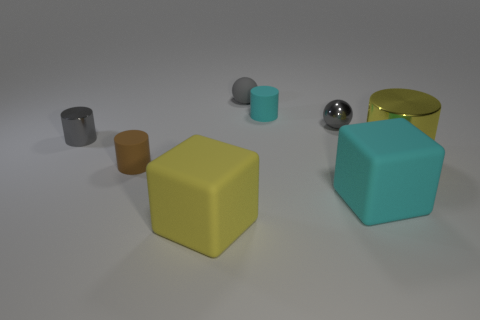Add 1 large yellow matte objects. How many objects exist? 9 Subtract all balls. How many objects are left? 6 Subtract 0 green cylinders. How many objects are left? 8 Subtract all gray shiny spheres. Subtract all brown matte things. How many objects are left? 6 Add 7 small gray objects. How many small gray objects are left? 10 Add 6 gray rubber spheres. How many gray rubber spheres exist? 7 